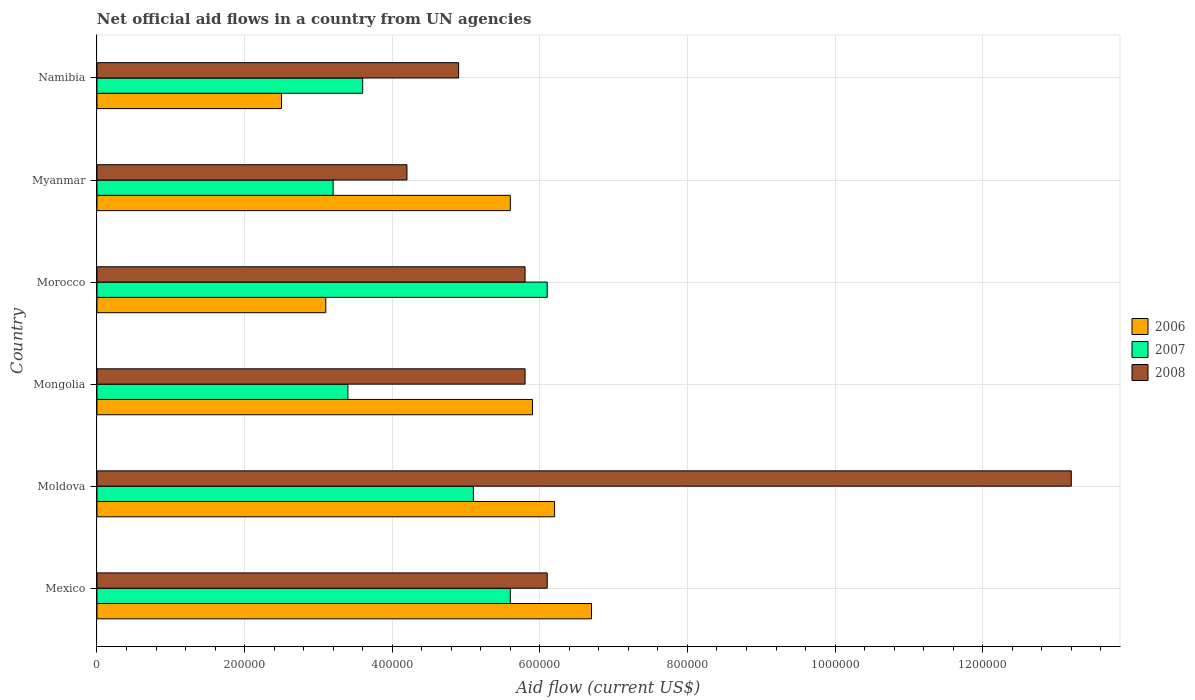Are the number of bars per tick equal to the number of legend labels?
Ensure brevity in your answer.  Yes. Are the number of bars on each tick of the Y-axis equal?
Offer a terse response. Yes. How many bars are there on the 5th tick from the bottom?
Offer a very short reply. 3. What is the label of the 2nd group of bars from the top?
Keep it short and to the point. Myanmar. Across all countries, what is the maximum net official aid flow in 2008?
Offer a very short reply. 1.32e+06. Across all countries, what is the minimum net official aid flow in 2008?
Offer a very short reply. 4.20e+05. In which country was the net official aid flow in 2007 maximum?
Your answer should be compact. Morocco. In which country was the net official aid flow in 2007 minimum?
Keep it short and to the point. Myanmar. What is the total net official aid flow in 2007 in the graph?
Keep it short and to the point. 2.70e+06. What is the difference between the net official aid flow in 2006 in Moldova and the net official aid flow in 2008 in Mexico?
Your answer should be compact. 10000. What is the average net official aid flow in 2008 per country?
Offer a terse response. 6.67e+05. What is the difference between the net official aid flow in 2007 and net official aid flow in 2008 in Moldova?
Offer a very short reply. -8.10e+05. In how many countries, is the net official aid flow in 2007 greater than 240000 US$?
Your response must be concise. 6. What is the ratio of the net official aid flow in 2008 in Mexico to that in Moldova?
Offer a very short reply. 0.46. What is the difference between the highest and the second highest net official aid flow in 2006?
Ensure brevity in your answer.  5.00e+04. In how many countries, is the net official aid flow in 2008 greater than the average net official aid flow in 2008 taken over all countries?
Keep it short and to the point. 1. Is it the case that in every country, the sum of the net official aid flow in 2006 and net official aid flow in 2007 is greater than the net official aid flow in 2008?
Keep it short and to the point. No. How many countries are there in the graph?
Provide a short and direct response. 6. What is the difference between two consecutive major ticks on the X-axis?
Ensure brevity in your answer.  2.00e+05. Are the values on the major ticks of X-axis written in scientific E-notation?
Give a very brief answer. No. Does the graph contain any zero values?
Give a very brief answer. No. Does the graph contain grids?
Provide a succinct answer. Yes. Where does the legend appear in the graph?
Make the answer very short. Center right. How many legend labels are there?
Provide a short and direct response. 3. How are the legend labels stacked?
Offer a terse response. Vertical. What is the title of the graph?
Offer a very short reply. Net official aid flows in a country from UN agencies. What is the label or title of the Y-axis?
Your response must be concise. Country. What is the Aid flow (current US$) in 2006 in Mexico?
Offer a very short reply. 6.70e+05. What is the Aid flow (current US$) of 2007 in Mexico?
Your response must be concise. 5.60e+05. What is the Aid flow (current US$) of 2008 in Mexico?
Offer a terse response. 6.10e+05. What is the Aid flow (current US$) of 2006 in Moldova?
Provide a short and direct response. 6.20e+05. What is the Aid flow (current US$) in 2007 in Moldova?
Provide a short and direct response. 5.10e+05. What is the Aid flow (current US$) in 2008 in Moldova?
Provide a short and direct response. 1.32e+06. What is the Aid flow (current US$) in 2006 in Mongolia?
Your response must be concise. 5.90e+05. What is the Aid flow (current US$) of 2008 in Mongolia?
Your answer should be compact. 5.80e+05. What is the Aid flow (current US$) of 2006 in Morocco?
Ensure brevity in your answer.  3.10e+05. What is the Aid flow (current US$) in 2007 in Morocco?
Ensure brevity in your answer.  6.10e+05. What is the Aid flow (current US$) in 2008 in Morocco?
Ensure brevity in your answer.  5.80e+05. What is the Aid flow (current US$) of 2006 in Myanmar?
Offer a terse response. 5.60e+05. What is the Aid flow (current US$) of 2008 in Namibia?
Your answer should be very brief. 4.90e+05. Across all countries, what is the maximum Aid flow (current US$) of 2006?
Your answer should be compact. 6.70e+05. Across all countries, what is the maximum Aid flow (current US$) in 2007?
Provide a succinct answer. 6.10e+05. Across all countries, what is the maximum Aid flow (current US$) in 2008?
Provide a short and direct response. 1.32e+06. Across all countries, what is the minimum Aid flow (current US$) in 2006?
Offer a very short reply. 2.50e+05. Across all countries, what is the minimum Aid flow (current US$) in 2007?
Keep it short and to the point. 3.20e+05. Across all countries, what is the minimum Aid flow (current US$) of 2008?
Ensure brevity in your answer.  4.20e+05. What is the total Aid flow (current US$) in 2006 in the graph?
Make the answer very short. 3.00e+06. What is the total Aid flow (current US$) in 2007 in the graph?
Your response must be concise. 2.70e+06. What is the total Aid flow (current US$) of 2008 in the graph?
Give a very brief answer. 4.00e+06. What is the difference between the Aid flow (current US$) of 2006 in Mexico and that in Moldova?
Your response must be concise. 5.00e+04. What is the difference between the Aid flow (current US$) of 2008 in Mexico and that in Moldova?
Offer a terse response. -7.10e+05. What is the difference between the Aid flow (current US$) of 2006 in Mexico and that in Mongolia?
Your response must be concise. 8.00e+04. What is the difference between the Aid flow (current US$) of 2007 in Mexico and that in Mongolia?
Make the answer very short. 2.20e+05. What is the difference between the Aid flow (current US$) of 2006 in Mexico and that in Morocco?
Keep it short and to the point. 3.60e+05. What is the difference between the Aid flow (current US$) of 2006 in Mexico and that in Myanmar?
Keep it short and to the point. 1.10e+05. What is the difference between the Aid flow (current US$) of 2007 in Mexico and that in Myanmar?
Provide a short and direct response. 2.40e+05. What is the difference between the Aid flow (current US$) of 2007 in Moldova and that in Mongolia?
Provide a short and direct response. 1.70e+05. What is the difference between the Aid flow (current US$) in 2008 in Moldova and that in Mongolia?
Your answer should be very brief. 7.40e+05. What is the difference between the Aid flow (current US$) in 2006 in Moldova and that in Morocco?
Your answer should be very brief. 3.10e+05. What is the difference between the Aid flow (current US$) in 2008 in Moldova and that in Morocco?
Your answer should be compact. 7.40e+05. What is the difference between the Aid flow (current US$) in 2007 in Moldova and that in Myanmar?
Your response must be concise. 1.90e+05. What is the difference between the Aid flow (current US$) in 2008 in Moldova and that in Myanmar?
Your answer should be very brief. 9.00e+05. What is the difference between the Aid flow (current US$) of 2008 in Moldova and that in Namibia?
Provide a succinct answer. 8.30e+05. What is the difference between the Aid flow (current US$) in 2006 in Mongolia and that in Morocco?
Give a very brief answer. 2.80e+05. What is the difference between the Aid flow (current US$) of 2008 in Mongolia and that in Morocco?
Provide a succinct answer. 0. What is the difference between the Aid flow (current US$) of 2006 in Mongolia and that in Myanmar?
Your answer should be compact. 3.00e+04. What is the difference between the Aid flow (current US$) in 2008 in Mongolia and that in Myanmar?
Your response must be concise. 1.60e+05. What is the difference between the Aid flow (current US$) of 2007 in Mongolia and that in Namibia?
Give a very brief answer. -2.00e+04. What is the difference between the Aid flow (current US$) in 2007 in Morocco and that in Myanmar?
Offer a very short reply. 2.90e+05. What is the difference between the Aid flow (current US$) of 2007 in Morocco and that in Namibia?
Offer a very short reply. 2.50e+05. What is the difference between the Aid flow (current US$) in 2008 in Morocco and that in Namibia?
Give a very brief answer. 9.00e+04. What is the difference between the Aid flow (current US$) of 2006 in Mexico and the Aid flow (current US$) of 2008 in Moldova?
Your answer should be compact. -6.50e+05. What is the difference between the Aid flow (current US$) in 2007 in Mexico and the Aid flow (current US$) in 2008 in Moldova?
Give a very brief answer. -7.60e+05. What is the difference between the Aid flow (current US$) in 2006 in Mexico and the Aid flow (current US$) in 2008 in Mongolia?
Ensure brevity in your answer.  9.00e+04. What is the difference between the Aid flow (current US$) in 2006 in Mexico and the Aid flow (current US$) in 2007 in Morocco?
Your answer should be very brief. 6.00e+04. What is the difference between the Aid flow (current US$) of 2006 in Mexico and the Aid flow (current US$) of 2008 in Morocco?
Offer a terse response. 9.00e+04. What is the difference between the Aid flow (current US$) of 2007 in Mexico and the Aid flow (current US$) of 2008 in Morocco?
Give a very brief answer. -2.00e+04. What is the difference between the Aid flow (current US$) in 2006 in Mexico and the Aid flow (current US$) in 2008 in Myanmar?
Keep it short and to the point. 2.50e+05. What is the difference between the Aid flow (current US$) of 2006 in Mexico and the Aid flow (current US$) of 2008 in Namibia?
Your response must be concise. 1.80e+05. What is the difference between the Aid flow (current US$) of 2007 in Mexico and the Aid flow (current US$) of 2008 in Namibia?
Offer a very short reply. 7.00e+04. What is the difference between the Aid flow (current US$) in 2006 in Moldova and the Aid flow (current US$) in 2007 in Mongolia?
Offer a terse response. 2.80e+05. What is the difference between the Aid flow (current US$) in 2006 in Moldova and the Aid flow (current US$) in 2008 in Mongolia?
Your response must be concise. 4.00e+04. What is the difference between the Aid flow (current US$) in 2006 in Moldova and the Aid flow (current US$) in 2007 in Morocco?
Your answer should be compact. 10000. What is the difference between the Aid flow (current US$) in 2006 in Moldova and the Aid flow (current US$) in 2007 in Namibia?
Provide a succinct answer. 2.60e+05. What is the difference between the Aid flow (current US$) of 2006 in Moldova and the Aid flow (current US$) of 2008 in Namibia?
Make the answer very short. 1.30e+05. What is the difference between the Aid flow (current US$) in 2007 in Moldova and the Aid flow (current US$) in 2008 in Namibia?
Provide a succinct answer. 2.00e+04. What is the difference between the Aid flow (current US$) of 2006 in Mongolia and the Aid flow (current US$) of 2007 in Morocco?
Keep it short and to the point. -2.00e+04. What is the difference between the Aid flow (current US$) in 2006 in Mongolia and the Aid flow (current US$) in 2008 in Morocco?
Ensure brevity in your answer.  10000. What is the difference between the Aid flow (current US$) of 2007 in Mongolia and the Aid flow (current US$) of 2008 in Morocco?
Provide a succinct answer. -2.40e+05. What is the difference between the Aid flow (current US$) in 2006 in Mongolia and the Aid flow (current US$) in 2007 in Myanmar?
Keep it short and to the point. 2.70e+05. What is the difference between the Aid flow (current US$) of 2006 in Mongolia and the Aid flow (current US$) of 2008 in Myanmar?
Offer a very short reply. 1.70e+05. What is the difference between the Aid flow (current US$) of 2006 in Mongolia and the Aid flow (current US$) of 2008 in Namibia?
Provide a succinct answer. 1.00e+05. What is the difference between the Aid flow (current US$) in 2007 in Mongolia and the Aid flow (current US$) in 2008 in Namibia?
Ensure brevity in your answer.  -1.50e+05. What is the difference between the Aid flow (current US$) in 2006 in Morocco and the Aid flow (current US$) in 2007 in Myanmar?
Provide a short and direct response. -10000. What is the difference between the Aid flow (current US$) in 2006 in Morocco and the Aid flow (current US$) in 2008 in Myanmar?
Your answer should be compact. -1.10e+05. What is the difference between the Aid flow (current US$) of 2006 in Morocco and the Aid flow (current US$) of 2007 in Namibia?
Give a very brief answer. -5.00e+04. What is the difference between the Aid flow (current US$) in 2006 in Myanmar and the Aid flow (current US$) in 2008 in Namibia?
Ensure brevity in your answer.  7.00e+04. What is the difference between the Aid flow (current US$) in 2007 in Myanmar and the Aid flow (current US$) in 2008 in Namibia?
Keep it short and to the point. -1.70e+05. What is the average Aid flow (current US$) of 2007 per country?
Ensure brevity in your answer.  4.50e+05. What is the average Aid flow (current US$) of 2008 per country?
Your response must be concise. 6.67e+05. What is the difference between the Aid flow (current US$) of 2006 and Aid flow (current US$) of 2008 in Mexico?
Ensure brevity in your answer.  6.00e+04. What is the difference between the Aid flow (current US$) in 2006 and Aid flow (current US$) in 2008 in Moldova?
Offer a very short reply. -7.00e+05. What is the difference between the Aid flow (current US$) in 2007 and Aid flow (current US$) in 2008 in Moldova?
Offer a very short reply. -8.10e+05. What is the difference between the Aid flow (current US$) of 2006 and Aid flow (current US$) of 2007 in Mongolia?
Provide a succinct answer. 2.50e+05. What is the difference between the Aid flow (current US$) of 2006 and Aid flow (current US$) of 2008 in Mongolia?
Give a very brief answer. 10000. What is the difference between the Aid flow (current US$) in 2006 and Aid flow (current US$) in 2007 in Myanmar?
Make the answer very short. 2.40e+05. What is the difference between the Aid flow (current US$) of 2006 and Aid flow (current US$) of 2007 in Namibia?
Ensure brevity in your answer.  -1.10e+05. What is the difference between the Aid flow (current US$) of 2006 and Aid flow (current US$) of 2008 in Namibia?
Offer a very short reply. -2.40e+05. What is the ratio of the Aid flow (current US$) in 2006 in Mexico to that in Moldova?
Your answer should be compact. 1.08. What is the ratio of the Aid flow (current US$) of 2007 in Mexico to that in Moldova?
Your response must be concise. 1.1. What is the ratio of the Aid flow (current US$) in 2008 in Mexico to that in Moldova?
Ensure brevity in your answer.  0.46. What is the ratio of the Aid flow (current US$) of 2006 in Mexico to that in Mongolia?
Offer a very short reply. 1.14. What is the ratio of the Aid flow (current US$) of 2007 in Mexico to that in Mongolia?
Make the answer very short. 1.65. What is the ratio of the Aid flow (current US$) in 2008 in Mexico to that in Mongolia?
Ensure brevity in your answer.  1.05. What is the ratio of the Aid flow (current US$) of 2006 in Mexico to that in Morocco?
Make the answer very short. 2.16. What is the ratio of the Aid flow (current US$) of 2007 in Mexico to that in Morocco?
Ensure brevity in your answer.  0.92. What is the ratio of the Aid flow (current US$) in 2008 in Mexico to that in Morocco?
Your answer should be compact. 1.05. What is the ratio of the Aid flow (current US$) of 2006 in Mexico to that in Myanmar?
Provide a succinct answer. 1.2. What is the ratio of the Aid flow (current US$) of 2007 in Mexico to that in Myanmar?
Provide a short and direct response. 1.75. What is the ratio of the Aid flow (current US$) in 2008 in Mexico to that in Myanmar?
Offer a terse response. 1.45. What is the ratio of the Aid flow (current US$) in 2006 in Mexico to that in Namibia?
Your response must be concise. 2.68. What is the ratio of the Aid flow (current US$) in 2007 in Mexico to that in Namibia?
Offer a terse response. 1.56. What is the ratio of the Aid flow (current US$) of 2008 in Mexico to that in Namibia?
Ensure brevity in your answer.  1.24. What is the ratio of the Aid flow (current US$) of 2006 in Moldova to that in Mongolia?
Your answer should be very brief. 1.05. What is the ratio of the Aid flow (current US$) of 2007 in Moldova to that in Mongolia?
Make the answer very short. 1.5. What is the ratio of the Aid flow (current US$) of 2008 in Moldova to that in Mongolia?
Make the answer very short. 2.28. What is the ratio of the Aid flow (current US$) in 2006 in Moldova to that in Morocco?
Offer a very short reply. 2. What is the ratio of the Aid flow (current US$) of 2007 in Moldova to that in Morocco?
Provide a short and direct response. 0.84. What is the ratio of the Aid flow (current US$) in 2008 in Moldova to that in Morocco?
Ensure brevity in your answer.  2.28. What is the ratio of the Aid flow (current US$) of 2006 in Moldova to that in Myanmar?
Offer a terse response. 1.11. What is the ratio of the Aid flow (current US$) in 2007 in Moldova to that in Myanmar?
Make the answer very short. 1.59. What is the ratio of the Aid flow (current US$) in 2008 in Moldova to that in Myanmar?
Provide a short and direct response. 3.14. What is the ratio of the Aid flow (current US$) in 2006 in Moldova to that in Namibia?
Provide a short and direct response. 2.48. What is the ratio of the Aid flow (current US$) in 2007 in Moldova to that in Namibia?
Keep it short and to the point. 1.42. What is the ratio of the Aid flow (current US$) of 2008 in Moldova to that in Namibia?
Make the answer very short. 2.69. What is the ratio of the Aid flow (current US$) of 2006 in Mongolia to that in Morocco?
Offer a very short reply. 1.9. What is the ratio of the Aid flow (current US$) of 2007 in Mongolia to that in Morocco?
Your answer should be very brief. 0.56. What is the ratio of the Aid flow (current US$) of 2008 in Mongolia to that in Morocco?
Your answer should be very brief. 1. What is the ratio of the Aid flow (current US$) in 2006 in Mongolia to that in Myanmar?
Your response must be concise. 1.05. What is the ratio of the Aid flow (current US$) in 2007 in Mongolia to that in Myanmar?
Offer a terse response. 1.06. What is the ratio of the Aid flow (current US$) of 2008 in Mongolia to that in Myanmar?
Your answer should be very brief. 1.38. What is the ratio of the Aid flow (current US$) of 2006 in Mongolia to that in Namibia?
Offer a very short reply. 2.36. What is the ratio of the Aid flow (current US$) of 2007 in Mongolia to that in Namibia?
Keep it short and to the point. 0.94. What is the ratio of the Aid flow (current US$) in 2008 in Mongolia to that in Namibia?
Give a very brief answer. 1.18. What is the ratio of the Aid flow (current US$) in 2006 in Morocco to that in Myanmar?
Offer a terse response. 0.55. What is the ratio of the Aid flow (current US$) of 2007 in Morocco to that in Myanmar?
Provide a short and direct response. 1.91. What is the ratio of the Aid flow (current US$) of 2008 in Morocco to that in Myanmar?
Provide a succinct answer. 1.38. What is the ratio of the Aid flow (current US$) in 2006 in Morocco to that in Namibia?
Your answer should be very brief. 1.24. What is the ratio of the Aid flow (current US$) in 2007 in Morocco to that in Namibia?
Your answer should be very brief. 1.69. What is the ratio of the Aid flow (current US$) in 2008 in Morocco to that in Namibia?
Offer a very short reply. 1.18. What is the ratio of the Aid flow (current US$) in 2006 in Myanmar to that in Namibia?
Make the answer very short. 2.24. What is the ratio of the Aid flow (current US$) of 2007 in Myanmar to that in Namibia?
Provide a short and direct response. 0.89. What is the difference between the highest and the second highest Aid flow (current US$) of 2006?
Your answer should be very brief. 5.00e+04. What is the difference between the highest and the second highest Aid flow (current US$) of 2008?
Keep it short and to the point. 7.10e+05. What is the difference between the highest and the lowest Aid flow (current US$) of 2006?
Provide a short and direct response. 4.20e+05. 